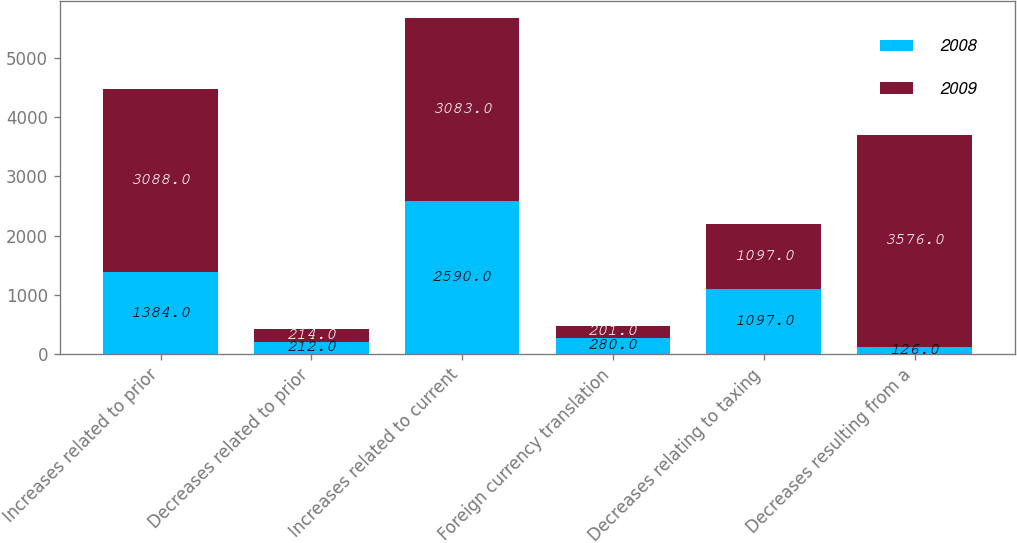<chart> <loc_0><loc_0><loc_500><loc_500><stacked_bar_chart><ecel><fcel>Increases related to prior<fcel>Decreases related to prior<fcel>Increases related to current<fcel>Foreign currency translation<fcel>Decreases relating to taxing<fcel>Decreases resulting from a<nl><fcel>2008<fcel>1384<fcel>212<fcel>2590<fcel>280<fcel>1097<fcel>126<nl><fcel>2009<fcel>3088<fcel>214<fcel>3083<fcel>201<fcel>1097<fcel>3576<nl></chart> 